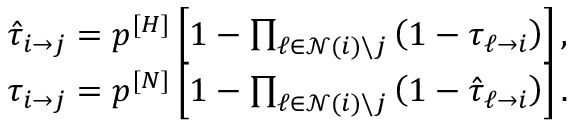Convert formula to latex. <formula><loc_0><loc_0><loc_500><loc_500>\begin{array} { r } { \hat { \tau } _ { i \rightarrow j } = p ^ { [ H ] } \left [ 1 - \prod _ { \ell \in \mathcal { N } ( i ) \ j } \left ( 1 - \tau _ { \ell \rightarrow i } \right ) \right ] , } \\ { \tau _ { i \rightarrow j } = p ^ { [ N ] } \left [ 1 - \prod _ { \ell \in \mathcal { N } ( i ) \ j } \left ( 1 - \hat { \tau } _ { \ell \rightarrow i } \right ) \right ] . } \end{array}</formula> 